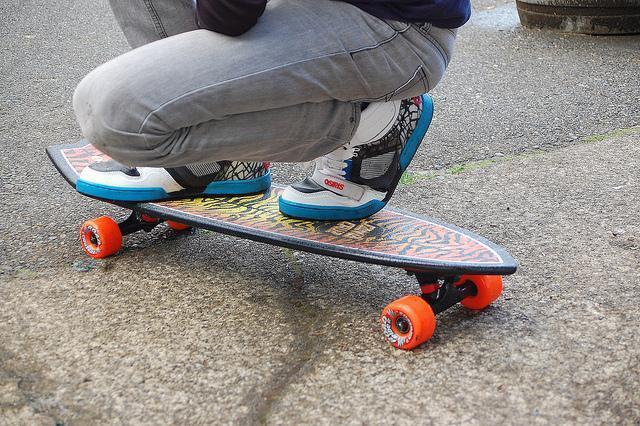How many skateboards are there?
Give a very brief answer. 1. How many cars in the picture are on the road?
Give a very brief answer. 0. 